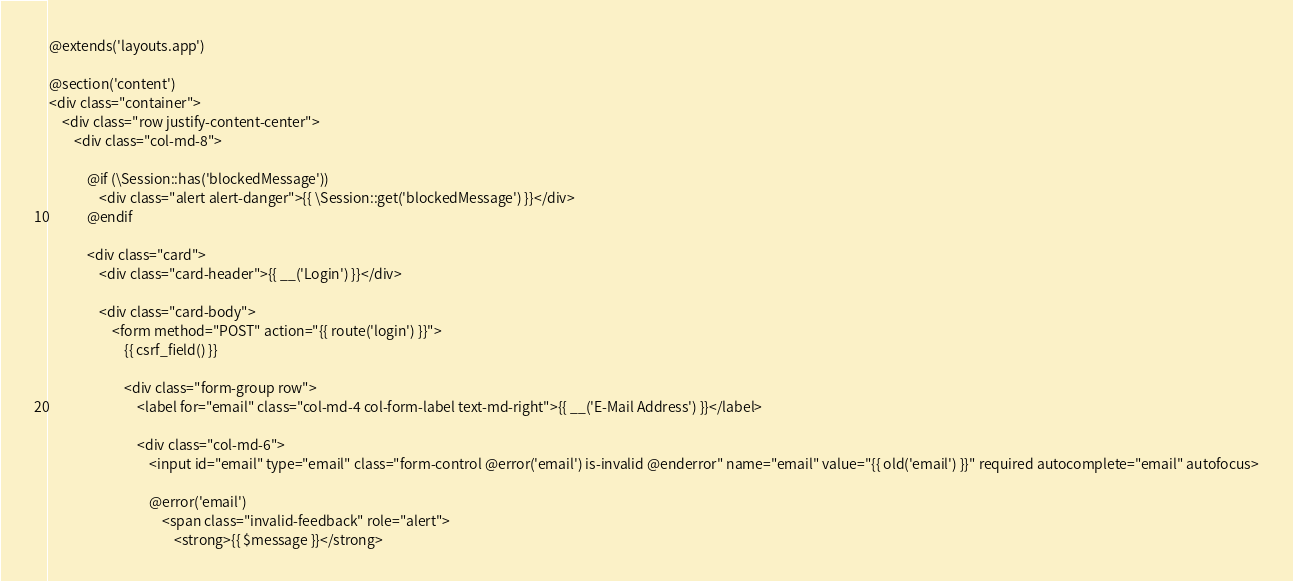<code> <loc_0><loc_0><loc_500><loc_500><_PHP_>@extends('layouts.app')

@section('content')
<div class="container">
    <div class="row justify-content-center">
        <div class="col-md-8">

            @if (\Session::has('blockedMessage'))
                <div class="alert alert-danger">{{ \Session::get('blockedMessage') }}</div>
            @endif

            <div class="card">
                <div class="card-header">{{ __('Login') }}</div>

                <div class="card-body">
                    <form method="POST" action="{{ route('login') }}">
                        {{ csrf_field() }}

                        <div class="form-group row">
                            <label for="email" class="col-md-4 col-form-label text-md-right">{{ __('E-Mail Address') }}</label>

                            <div class="col-md-6">
                                <input id="email" type="email" class="form-control @error('email') is-invalid @enderror" name="email" value="{{ old('email') }}" required autocomplete="email" autofocus>

                                @error('email')
                                    <span class="invalid-feedback" role="alert">
                                        <strong>{{ $message }}</strong></code> 